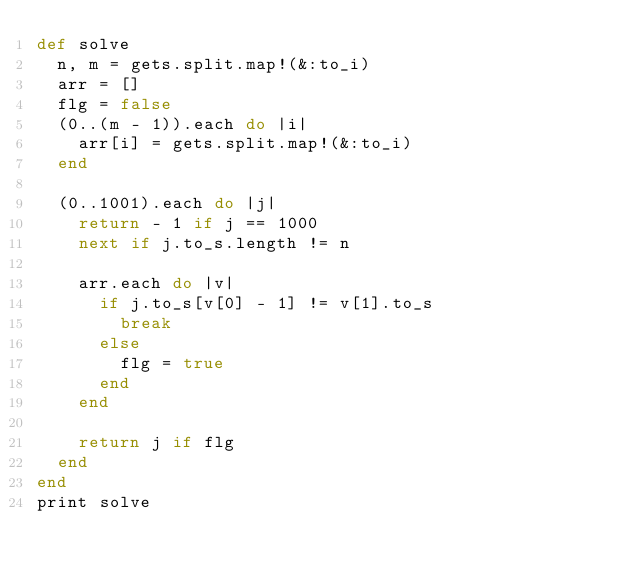Convert code to text. <code><loc_0><loc_0><loc_500><loc_500><_Ruby_>def solve
  n, m = gets.split.map!(&:to_i)
  arr = []
  flg = false
  (0..(m - 1)).each do |i|
    arr[i] = gets.split.map!(&:to_i)
  end

  (0..1001).each do |j|
    return - 1 if j == 1000
    next if j.to_s.length != n

    arr.each do |v|
      if j.to_s[v[0] - 1] != v[1].to_s
        break
      else
        flg = true
      end
    end

    return j if flg
  end
end
print solve
</code> 